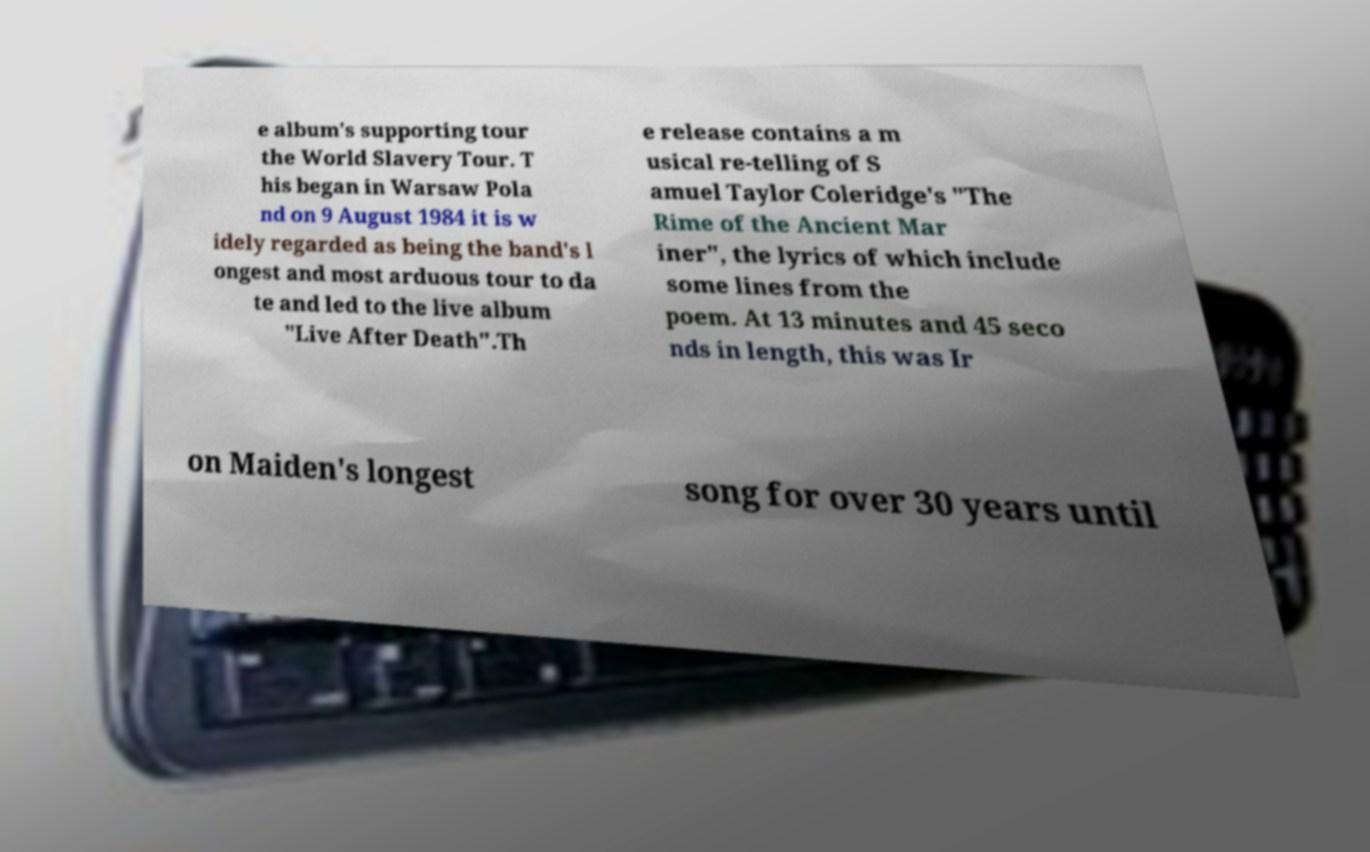For documentation purposes, I need the text within this image transcribed. Could you provide that? e album's supporting tour the World Slavery Tour. T his began in Warsaw Pola nd on 9 August 1984 it is w idely regarded as being the band's l ongest and most arduous tour to da te and led to the live album "Live After Death".Th e release contains a m usical re-telling of S amuel Taylor Coleridge's "The Rime of the Ancient Mar iner", the lyrics of which include some lines from the poem. At 13 minutes and 45 seco nds in length, this was Ir on Maiden's longest song for over 30 years until 